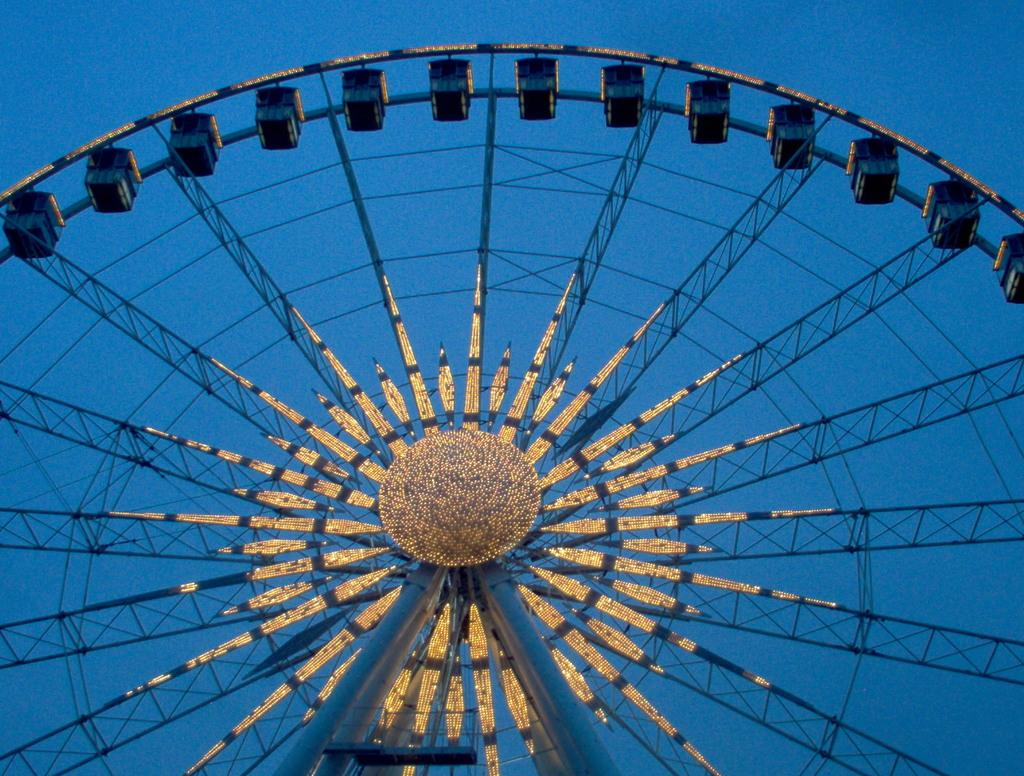What is the main subject in the image? There is a giant wheel in the image. What can be seen in the background of the image? The sky is visible in the background of the image. What type of dinner is being served on the giant wheel in the image? There is no dinner or any food present on the giant wheel in the image. 